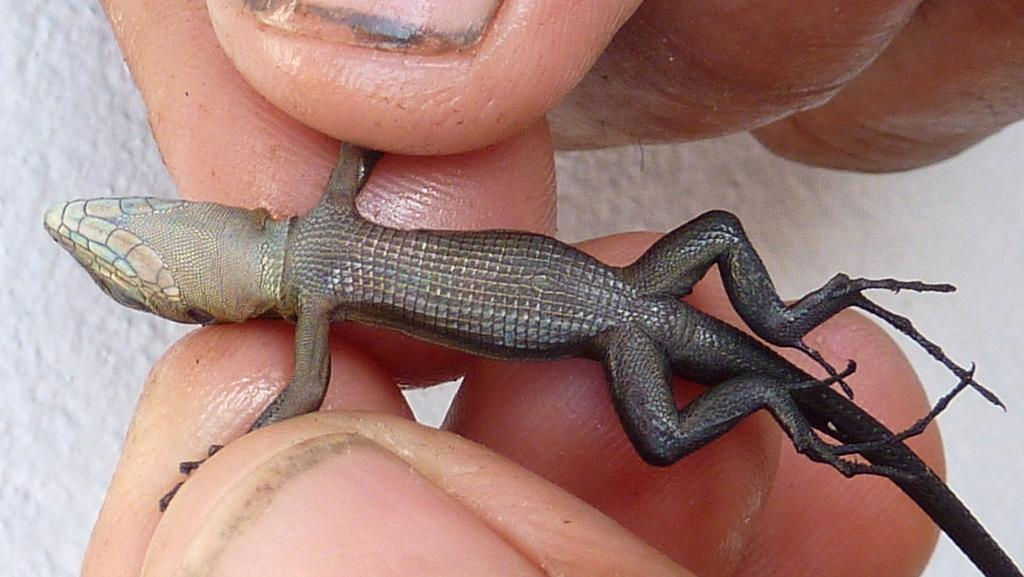What is the main subject of the image? There is a person in the image. What is the person doing in the image? The person's hands are holding a lizard. What type of cannon is present in the image? There is no cannon present in the image. What month is depicted in the image? The image does not depict a specific month or time of year. 